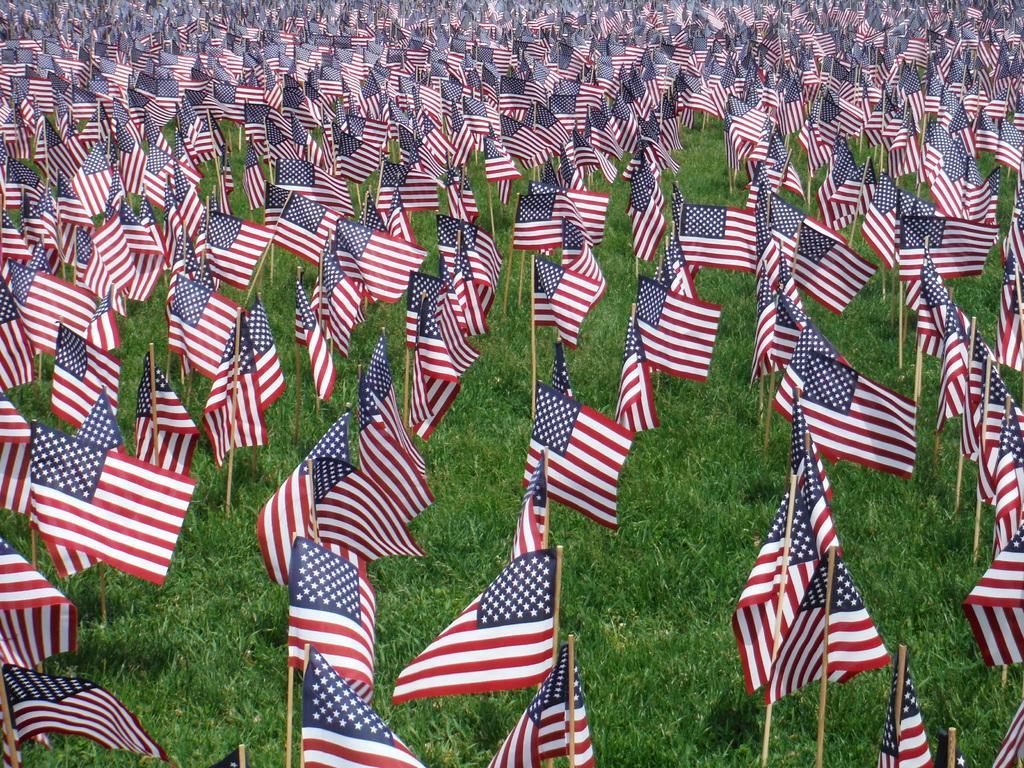Could you give a brief overview of what you see in this image? There are many flags in this grass. 